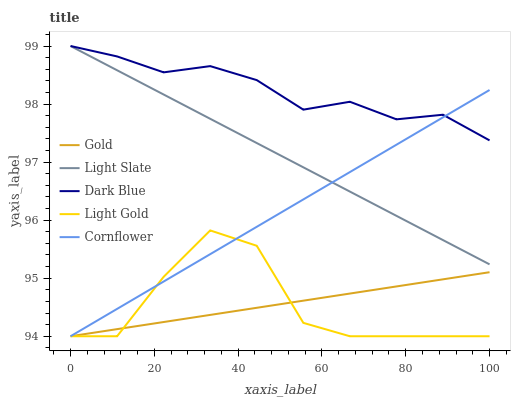Does Light Gold have the minimum area under the curve?
Answer yes or no. Yes. Does Dark Blue have the maximum area under the curve?
Answer yes or no. Yes. Does Dark Blue have the minimum area under the curve?
Answer yes or no. No. Does Light Gold have the maximum area under the curve?
Answer yes or no. No. Is Light Slate the smoothest?
Answer yes or no. Yes. Is Light Gold the roughest?
Answer yes or no. Yes. Is Dark Blue the smoothest?
Answer yes or no. No. Is Dark Blue the roughest?
Answer yes or no. No. Does Light Gold have the lowest value?
Answer yes or no. Yes. Does Dark Blue have the lowest value?
Answer yes or no. No. Does Dark Blue have the highest value?
Answer yes or no. Yes. Does Light Gold have the highest value?
Answer yes or no. No. Is Gold less than Dark Blue?
Answer yes or no. Yes. Is Light Slate greater than Gold?
Answer yes or no. Yes. Does Cornflower intersect Light Gold?
Answer yes or no. Yes. Is Cornflower less than Light Gold?
Answer yes or no. No. Is Cornflower greater than Light Gold?
Answer yes or no. No. Does Gold intersect Dark Blue?
Answer yes or no. No. 